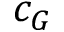Convert formula to latex. <formula><loc_0><loc_0><loc_500><loc_500>c _ { G }</formula> 